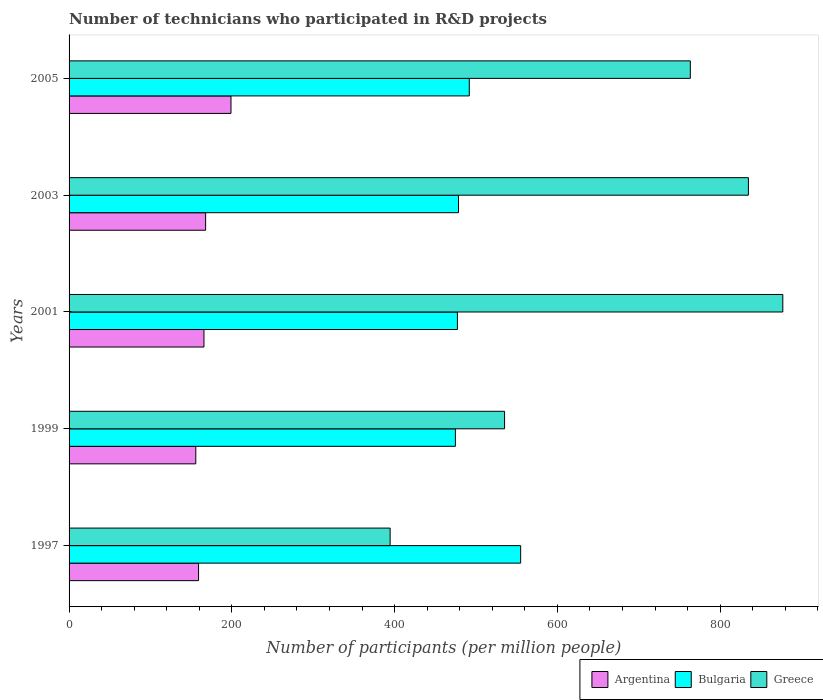Are the number of bars per tick equal to the number of legend labels?
Your answer should be compact. Yes. Are the number of bars on each tick of the Y-axis equal?
Offer a very short reply. Yes. How many bars are there on the 4th tick from the top?
Provide a succinct answer. 3. In how many cases, is the number of bars for a given year not equal to the number of legend labels?
Offer a very short reply. 0. What is the number of technicians who participated in R&D projects in Greece in 1997?
Your response must be concise. 394.52. Across all years, what is the maximum number of technicians who participated in R&D projects in Greece?
Give a very brief answer. 877.01. Across all years, what is the minimum number of technicians who participated in R&D projects in Greece?
Provide a succinct answer. 394.52. In which year was the number of technicians who participated in R&D projects in Argentina maximum?
Your response must be concise. 2005. In which year was the number of technicians who participated in R&D projects in Greece minimum?
Provide a short and direct response. 1997. What is the total number of technicians who participated in R&D projects in Greece in the graph?
Offer a very short reply. 3404.79. What is the difference between the number of technicians who participated in R&D projects in Greece in 1999 and that in 2005?
Give a very brief answer. -228.24. What is the difference between the number of technicians who participated in R&D projects in Bulgaria in 2005 and the number of technicians who participated in R&D projects in Greece in 2003?
Ensure brevity in your answer.  -342.98. What is the average number of technicians who participated in R&D projects in Argentina per year?
Provide a succinct answer. 169.47. In the year 2005, what is the difference between the number of technicians who participated in R&D projects in Bulgaria and number of technicians who participated in R&D projects in Greece?
Your response must be concise. -271.62. What is the ratio of the number of technicians who participated in R&D projects in Bulgaria in 1999 to that in 2005?
Give a very brief answer. 0.97. Is the number of technicians who participated in R&D projects in Greece in 1999 less than that in 2005?
Offer a very short reply. Yes. Is the difference between the number of technicians who participated in R&D projects in Bulgaria in 1997 and 2001 greater than the difference between the number of technicians who participated in R&D projects in Greece in 1997 and 2001?
Give a very brief answer. Yes. What is the difference between the highest and the second highest number of technicians who participated in R&D projects in Argentina?
Offer a terse response. 31.16. What is the difference between the highest and the lowest number of technicians who participated in R&D projects in Argentina?
Your response must be concise. 43.23. In how many years, is the number of technicians who participated in R&D projects in Argentina greater than the average number of technicians who participated in R&D projects in Argentina taken over all years?
Provide a succinct answer. 1. How many years are there in the graph?
Your answer should be compact. 5. Does the graph contain any zero values?
Keep it short and to the point. No. Where does the legend appear in the graph?
Keep it short and to the point. Bottom right. How are the legend labels stacked?
Give a very brief answer. Horizontal. What is the title of the graph?
Your answer should be compact. Number of technicians who participated in R&D projects. Does "Paraguay" appear as one of the legend labels in the graph?
Your answer should be very brief. No. What is the label or title of the X-axis?
Ensure brevity in your answer.  Number of participants (per million people). What is the label or title of the Y-axis?
Provide a short and direct response. Years. What is the Number of participants (per million people) of Argentina in 1997?
Make the answer very short. 159.12. What is the Number of participants (per million people) of Bulgaria in 1997?
Keep it short and to the point. 554.88. What is the Number of participants (per million people) of Greece in 1997?
Your answer should be compact. 394.52. What is the Number of participants (per million people) of Argentina in 1999?
Ensure brevity in your answer.  155.72. What is the Number of participants (per million people) of Bulgaria in 1999?
Keep it short and to the point. 474.7. What is the Number of participants (per million people) in Greece in 1999?
Offer a very short reply. 535.14. What is the Number of participants (per million people) in Argentina in 2001?
Your response must be concise. 165.75. What is the Number of participants (per million people) in Bulgaria in 2001?
Keep it short and to the point. 477.16. What is the Number of participants (per million people) in Greece in 2001?
Keep it short and to the point. 877.01. What is the Number of participants (per million people) in Argentina in 2003?
Provide a succinct answer. 167.79. What is the Number of participants (per million people) in Bulgaria in 2003?
Give a very brief answer. 478.54. What is the Number of participants (per million people) in Greece in 2003?
Provide a short and direct response. 834.74. What is the Number of participants (per million people) of Argentina in 2005?
Make the answer very short. 198.95. What is the Number of participants (per million people) in Bulgaria in 2005?
Your answer should be very brief. 491.76. What is the Number of participants (per million people) of Greece in 2005?
Your response must be concise. 763.38. Across all years, what is the maximum Number of participants (per million people) in Argentina?
Your answer should be very brief. 198.95. Across all years, what is the maximum Number of participants (per million people) in Bulgaria?
Provide a succinct answer. 554.88. Across all years, what is the maximum Number of participants (per million people) of Greece?
Give a very brief answer. 877.01. Across all years, what is the minimum Number of participants (per million people) in Argentina?
Keep it short and to the point. 155.72. Across all years, what is the minimum Number of participants (per million people) in Bulgaria?
Offer a very short reply. 474.7. Across all years, what is the minimum Number of participants (per million people) in Greece?
Offer a very short reply. 394.52. What is the total Number of participants (per million people) of Argentina in the graph?
Offer a terse response. 847.34. What is the total Number of participants (per million people) in Bulgaria in the graph?
Your answer should be compact. 2477.04. What is the total Number of participants (per million people) in Greece in the graph?
Your response must be concise. 3404.79. What is the difference between the Number of participants (per million people) of Argentina in 1997 and that in 1999?
Ensure brevity in your answer.  3.4. What is the difference between the Number of participants (per million people) in Bulgaria in 1997 and that in 1999?
Give a very brief answer. 80.19. What is the difference between the Number of participants (per million people) in Greece in 1997 and that in 1999?
Ensure brevity in your answer.  -140.62. What is the difference between the Number of participants (per million people) of Argentina in 1997 and that in 2001?
Give a very brief answer. -6.63. What is the difference between the Number of participants (per million people) of Bulgaria in 1997 and that in 2001?
Provide a short and direct response. 77.72. What is the difference between the Number of participants (per million people) of Greece in 1997 and that in 2001?
Provide a short and direct response. -482.49. What is the difference between the Number of participants (per million people) of Argentina in 1997 and that in 2003?
Your response must be concise. -8.67. What is the difference between the Number of participants (per million people) of Bulgaria in 1997 and that in 2003?
Ensure brevity in your answer.  76.35. What is the difference between the Number of participants (per million people) of Greece in 1997 and that in 2003?
Provide a short and direct response. -440.22. What is the difference between the Number of participants (per million people) of Argentina in 1997 and that in 2005?
Your answer should be compact. -39.83. What is the difference between the Number of participants (per million people) in Bulgaria in 1997 and that in 2005?
Make the answer very short. 63.12. What is the difference between the Number of participants (per million people) in Greece in 1997 and that in 2005?
Your answer should be very brief. -368.86. What is the difference between the Number of participants (per million people) of Argentina in 1999 and that in 2001?
Provide a short and direct response. -10.03. What is the difference between the Number of participants (per million people) of Bulgaria in 1999 and that in 2001?
Give a very brief answer. -2.47. What is the difference between the Number of participants (per million people) of Greece in 1999 and that in 2001?
Ensure brevity in your answer.  -341.87. What is the difference between the Number of participants (per million people) of Argentina in 1999 and that in 2003?
Your answer should be compact. -12.07. What is the difference between the Number of participants (per million people) in Bulgaria in 1999 and that in 2003?
Offer a terse response. -3.84. What is the difference between the Number of participants (per million people) of Greece in 1999 and that in 2003?
Your answer should be very brief. -299.6. What is the difference between the Number of participants (per million people) of Argentina in 1999 and that in 2005?
Offer a very short reply. -43.23. What is the difference between the Number of participants (per million people) of Bulgaria in 1999 and that in 2005?
Your answer should be very brief. -17.06. What is the difference between the Number of participants (per million people) of Greece in 1999 and that in 2005?
Your answer should be compact. -228.24. What is the difference between the Number of participants (per million people) of Argentina in 2001 and that in 2003?
Provide a succinct answer. -2.04. What is the difference between the Number of participants (per million people) of Bulgaria in 2001 and that in 2003?
Keep it short and to the point. -1.37. What is the difference between the Number of participants (per million people) of Greece in 2001 and that in 2003?
Your response must be concise. 42.27. What is the difference between the Number of participants (per million people) of Argentina in 2001 and that in 2005?
Your answer should be compact. -33.2. What is the difference between the Number of participants (per million people) in Bulgaria in 2001 and that in 2005?
Provide a short and direct response. -14.6. What is the difference between the Number of participants (per million people) of Greece in 2001 and that in 2005?
Keep it short and to the point. 113.63. What is the difference between the Number of participants (per million people) in Argentina in 2003 and that in 2005?
Offer a very short reply. -31.16. What is the difference between the Number of participants (per million people) of Bulgaria in 2003 and that in 2005?
Give a very brief answer. -13.22. What is the difference between the Number of participants (per million people) of Greece in 2003 and that in 2005?
Give a very brief answer. 71.35. What is the difference between the Number of participants (per million people) in Argentina in 1997 and the Number of participants (per million people) in Bulgaria in 1999?
Give a very brief answer. -315.57. What is the difference between the Number of participants (per million people) in Argentina in 1997 and the Number of participants (per million people) in Greece in 1999?
Your answer should be very brief. -376.02. What is the difference between the Number of participants (per million people) of Bulgaria in 1997 and the Number of participants (per million people) of Greece in 1999?
Make the answer very short. 19.74. What is the difference between the Number of participants (per million people) in Argentina in 1997 and the Number of participants (per million people) in Bulgaria in 2001?
Offer a terse response. -318.04. What is the difference between the Number of participants (per million people) in Argentina in 1997 and the Number of participants (per million people) in Greece in 2001?
Make the answer very short. -717.89. What is the difference between the Number of participants (per million people) in Bulgaria in 1997 and the Number of participants (per million people) in Greece in 2001?
Your answer should be compact. -322.13. What is the difference between the Number of participants (per million people) of Argentina in 1997 and the Number of participants (per million people) of Bulgaria in 2003?
Offer a terse response. -319.41. What is the difference between the Number of participants (per million people) of Argentina in 1997 and the Number of participants (per million people) of Greece in 2003?
Your answer should be compact. -675.61. What is the difference between the Number of participants (per million people) of Bulgaria in 1997 and the Number of participants (per million people) of Greece in 2003?
Your response must be concise. -279.85. What is the difference between the Number of participants (per million people) in Argentina in 1997 and the Number of participants (per million people) in Bulgaria in 2005?
Give a very brief answer. -332.64. What is the difference between the Number of participants (per million people) in Argentina in 1997 and the Number of participants (per million people) in Greece in 2005?
Provide a succinct answer. -604.26. What is the difference between the Number of participants (per million people) in Bulgaria in 1997 and the Number of participants (per million people) in Greece in 2005?
Make the answer very short. -208.5. What is the difference between the Number of participants (per million people) in Argentina in 1999 and the Number of participants (per million people) in Bulgaria in 2001?
Your answer should be compact. -321.44. What is the difference between the Number of participants (per million people) in Argentina in 1999 and the Number of participants (per million people) in Greece in 2001?
Ensure brevity in your answer.  -721.29. What is the difference between the Number of participants (per million people) of Bulgaria in 1999 and the Number of participants (per million people) of Greece in 2001?
Your response must be concise. -402.32. What is the difference between the Number of participants (per million people) of Argentina in 1999 and the Number of participants (per million people) of Bulgaria in 2003?
Give a very brief answer. -322.81. What is the difference between the Number of participants (per million people) of Argentina in 1999 and the Number of participants (per million people) of Greece in 2003?
Offer a very short reply. -679.01. What is the difference between the Number of participants (per million people) in Bulgaria in 1999 and the Number of participants (per million people) in Greece in 2003?
Give a very brief answer. -360.04. What is the difference between the Number of participants (per million people) in Argentina in 1999 and the Number of participants (per million people) in Bulgaria in 2005?
Provide a succinct answer. -336.04. What is the difference between the Number of participants (per million people) of Argentina in 1999 and the Number of participants (per million people) of Greece in 2005?
Your response must be concise. -607.66. What is the difference between the Number of participants (per million people) in Bulgaria in 1999 and the Number of participants (per million people) in Greece in 2005?
Ensure brevity in your answer.  -288.69. What is the difference between the Number of participants (per million people) of Argentina in 2001 and the Number of participants (per million people) of Bulgaria in 2003?
Keep it short and to the point. -312.78. What is the difference between the Number of participants (per million people) of Argentina in 2001 and the Number of participants (per million people) of Greece in 2003?
Your response must be concise. -668.99. What is the difference between the Number of participants (per million people) in Bulgaria in 2001 and the Number of participants (per million people) in Greece in 2003?
Your answer should be compact. -357.57. What is the difference between the Number of participants (per million people) of Argentina in 2001 and the Number of participants (per million people) of Bulgaria in 2005?
Make the answer very short. -326.01. What is the difference between the Number of participants (per million people) in Argentina in 2001 and the Number of participants (per million people) in Greece in 2005?
Keep it short and to the point. -597.63. What is the difference between the Number of participants (per million people) in Bulgaria in 2001 and the Number of participants (per million people) in Greece in 2005?
Offer a terse response. -286.22. What is the difference between the Number of participants (per million people) of Argentina in 2003 and the Number of participants (per million people) of Bulgaria in 2005?
Your answer should be compact. -323.97. What is the difference between the Number of participants (per million people) in Argentina in 2003 and the Number of participants (per million people) in Greece in 2005?
Provide a short and direct response. -595.59. What is the difference between the Number of participants (per million people) in Bulgaria in 2003 and the Number of participants (per million people) in Greece in 2005?
Provide a succinct answer. -284.85. What is the average Number of participants (per million people) in Argentina per year?
Give a very brief answer. 169.47. What is the average Number of participants (per million people) of Bulgaria per year?
Provide a succinct answer. 495.41. What is the average Number of participants (per million people) of Greece per year?
Ensure brevity in your answer.  680.96. In the year 1997, what is the difference between the Number of participants (per million people) in Argentina and Number of participants (per million people) in Bulgaria?
Make the answer very short. -395.76. In the year 1997, what is the difference between the Number of participants (per million people) of Argentina and Number of participants (per million people) of Greece?
Your answer should be compact. -235.4. In the year 1997, what is the difference between the Number of participants (per million people) in Bulgaria and Number of participants (per million people) in Greece?
Offer a very short reply. 160.36. In the year 1999, what is the difference between the Number of participants (per million people) in Argentina and Number of participants (per million people) in Bulgaria?
Offer a terse response. -318.97. In the year 1999, what is the difference between the Number of participants (per million people) of Argentina and Number of participants (per million people) of Greece?
Give a very brief answer. -379.41. In the year 1999, what is the difference between the Number of participants (per million people) of Bulgaria and Number of participants (per million people) of Greece?
Ensure brevity in your answer.  -60.44. In the year 2001, what is the difference between the Number of participants (per million people) of Argentina and Number of participants (per million people) of Bulgaria?
Your answer should be very brief. -311.41. In the year 2001, what is the difference between the Number of participants (per million people) of Argentina and Number of participants (per million people) of Greece?
Your response must be concise. -711.26. In the year 2001, what is the difference between the Number of participants (per million people) of Bulgaria and Number of participants (per million people) of Greece?
Keep it short and to the point. -399.85. In the year 2003, what is the difference between the Number of participants (per million people) in Argentina and Number of participants (per million people) in Bulgaria?
Give a very brief answer. -310.75. In the year 2003, what is the difference between the Number of participants (per million people) of Argentina and Number of participants (per million people) of Greece?
Your response must be concise. -666.95. In the year 2003, what is the difference between the Number of participants (per million people) of Bulgaria and Number of participants (per million people) of Greece?
Provide a succinct answer. -356.2. In the year 2005, what is the difference between the Number of participants (per million people) of Argentina and Number of participants (per million people) of Bulgaria?
Ensure brevity in your answer.  -292.81. In the year 2005, what is the difference between the Number of participants (per million people) in Argentina and Number of participants (per million people) in Greece?
Provide a succinct answer. -564.43. In the year 2005, what is the difference between the Number of participants (per million people) in Bulgaria and Number of participants (per million people) in Greece?
Your answer should be very brief. -271.62. What is the ratio of the Number of participants (per million people) in Argentina in 1997 to that in 1999?
Keep it short and to the point. 1.02. What is the ratio of the Number of participants (per million people) in Bulgaria in 1997 to that in 1999?
Offer a very short reply. 1.17. What is the ratio of the Number of participants (per million people) of Greece in 1997 to that in 1999?
Provide a short and direct response. 0.74. What is the ratio of the Number of participants (per million people) of Argentina in 1997 to that in 2001?
Offer a terse response. 0.96. What is the ratio of the Number of participants (per million people) in Bulgaria in 1997 to that in 2001?
Your answer should be very brief. 1.16. What is the ratio of the Number of participants (per million people) of Greece in 1997 to that in 2001?
Your answer should be very brief. 0.45. What is the ratio of the Number of participants (per million people) in Argentina in 1997 to that in 2003?
Your answer should be compact. 0.95. What is the ratio of the Number of participants (per million people) in Bulgaria in 1997 to that in 2003?
Make the answer very short. 1.16. What is the ratio of the Number of participants (per million people) of Greece in 1997 to that in 2003?
Offer a terse response. 0.47. What is the ratio of the Number of participants (per million people) in Argentina in 1997 to that in 2005?
Your response must be concise. 0.8. What is the ratio of the Number of participants (per million people) of Bulgaria in 1997 to that in 2005?
Ensure brevity in your answer.  1.13. What is the ratio of the Number of participants (per million people) of Greece in 1997 to that in 2005?
Ensure brevity in your answer.  0.52. What is the ratio of the Number of participants (per million people) of Argentina in 1999 to that in 2001?
Your answer should be compact. 0.94. What is the ratio of the Number of participants (per million people) of Bulgaria in 1999 to that in 2001?
Provide a short and direct response. 0.99. What is the ratio of the Number of participants (per million people) in Greece in 1999 to that in 2001?
Give a very brief answer. 0.61. What is the ratio of the Number of participants (per million people) in Argentina in 1999 to that in 2003?
Provide a succinct answer. 0.93. What is the ratio of the Number of participants (per million people) of Bulgaria in 1999 to that in 2003?
Provide a succinct answer. 0.99. What is the ratio of the Number of participants (per million people) of Greece in 1999 to that in 2003?
Your answer should be very brief. 0.64. What is the ratio of the Number of participants (per million people) in Argentina in 1999 to that in 2005?
Your answer should be compact. 0.78. What is the ratio of the Number of participants (per million people) of Bulgaria in 1999 to that in 2005?
Make the answer very short. 0.97. What is the ratio of the Number of participants (per million people) of Greece in 1999 to that in 2005?
Provide a short and direct response. 0.7. What is the ratio of the Number of participants (per million people) of Argentina in 2001 to that in 2003?
Keep it short and to the point. 0.99. What is the ratio of the Number of participants (per million people) in Bulgaria in 2001 to that in 2003?
Make the answer very short. 1. What is the ratio of the Number of participants (per million people) in Greece in 2001 to that in 2003?
Provide a succinct answer. 1.05. What is the ratio of the Number of participants (per million people) of Argentina in 2001 to that in 2005?
Provide a short and direct response. 0.83. What is the ratio of the Number of participants (per million people) in Bulgaria in 2001 to that in 2005?
Your response must be concise. 0.97. What is the ratio of the Number of participants (per million people) of Greece in 2001 to that in 2005?
Make the answer very short. 1.15. What is the ratio of the Number of participants (per million people) in Argentina in 2003 to that in 2005?
Offer a very short reply. 0.84. What is the ratio of the Number of participants (per million people) of Bulgaria in 2003 to that in 2005?
Offer a terse response. 0.97. What is the ratio of the Number of participants (per million people) of Greece in 2003 to that in 2005?
Your answer should be very brief. 1.09. What is the difference between the highest and the second highest Number of participants (per million people) in Argentina?
Your answer should be compact. 31.16. What is the difference between the highest and the second highest Number of participants (per million people) of Bulgaria?
Ensure brevity in your answer.  63.12. What is the difference between the highest and the second highest Number of participants (per million people) in Greece?
Offer a terse response. 42.27. What is the difference between the highest and the lowest Number of participants (per million people) in Argentina?
Your answer should be very brief. 43.23. What is the difference between the highest and the lowest Number of participants (per million people) of Bulgaria?
Keep it short and to the point. 80.19. What is the difference between the highest and the lowest Number of participants (per million people) of Greece?
Offer a very short reply. 482.49. 